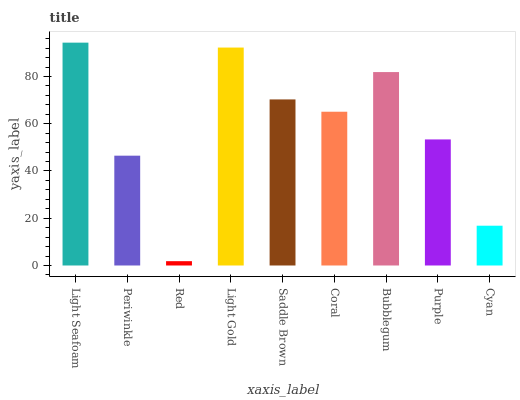Is Red the minimum?
Answer yes or no. Yes. Is Light Seafoam the maximum?
Answer yes or no. Yes. Is Periwinkle the minimum?
Answer yes or no. No. Is Periwinkle the maximum?
Answer yes or no. No. Is Light Seafoam greater than Periwinkle?
Answer yes or no. Yes. Is Periwinkle less than Light Seafoam?
Answer yes or no. Yes. Is Periwinkle greater than Light Seafoam?
Answer yes or no. No. Is Light Seafoam less than Periwinkle?
Answer yes or no. No. Is Coral the high median?
Answer yes or no. Yes. Is Coral the low median?
Answer yes or no. Yes. Is Light Seafoam the high median?
Answer yes or no. No. Is Purple the low median?
Answer yes or no. No. 